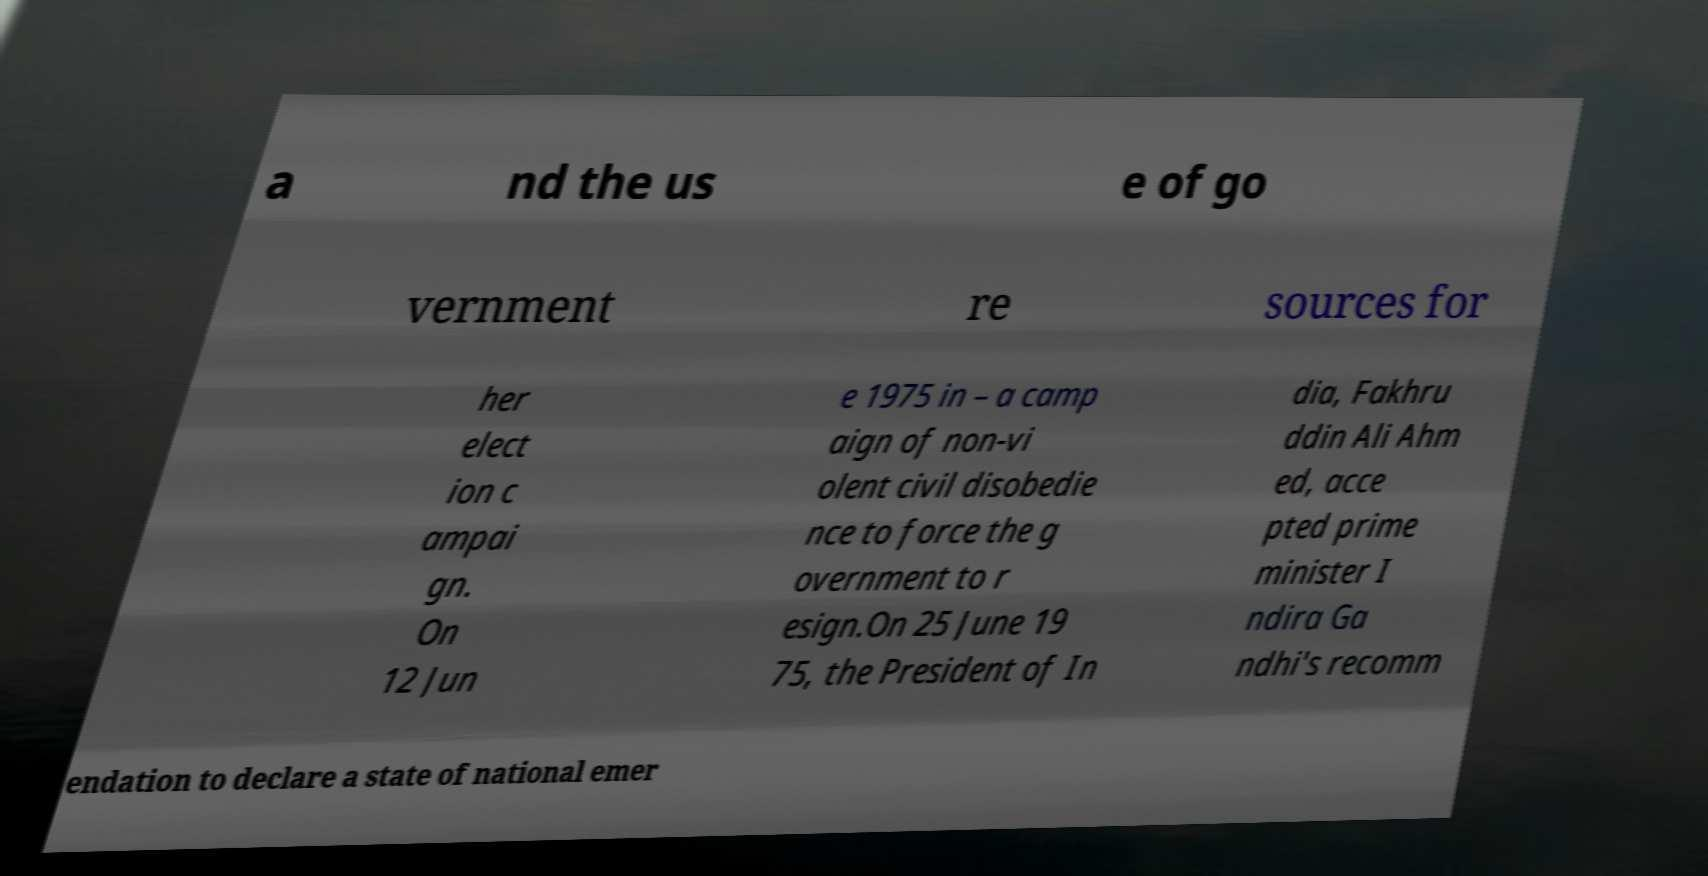I need the written content from this picture converted into text. Can you do that? a nd the us e of go vernment re sources for her elect ion c ampai gn. On 12 Jun e 1975 in – a camp aign of non-vi olent civil disobedie nce to force the g overnment to r esign.On 25 June 19 75, the President of In dia, Fakhru ddin Ali Ahm ed, acce pted prime minister I ndira Ga ndhi's recomm endation to declare a state of national emer 